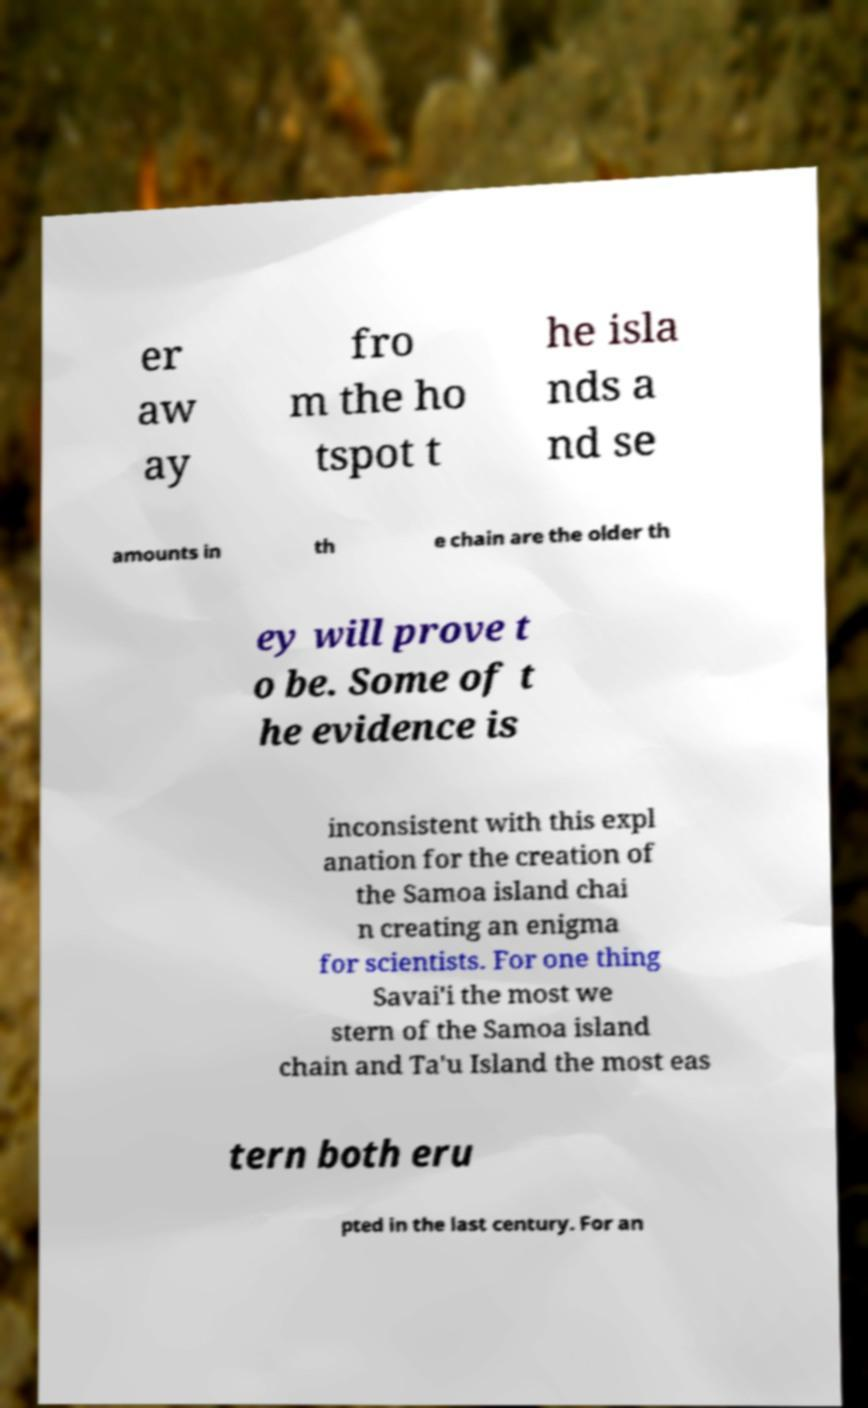I need the written content from this picture converted into text. Can you do that? er aw ay fro m the ho tspot t he isla nds a nd se amounts in th e chain are the older th ey will prove t o be. Some of t he evidence is inconsistent with this expl anation for the creation of the Samoa island chai n creating an enigma for scientists. For one thing Savai'i the most we stern of the Samoa island chain and Ta'u Island the most eas tern both eru pted in the last century. For an 